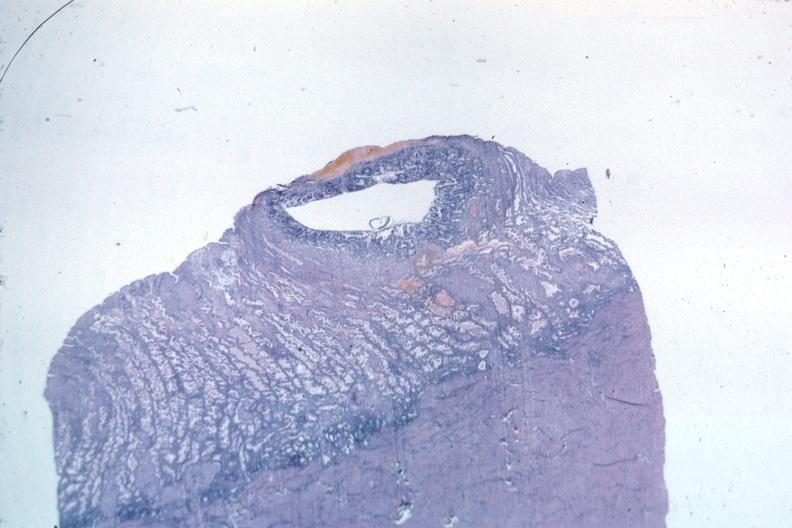s uterus present?
Answer the question using a single word or phrase. Yes 